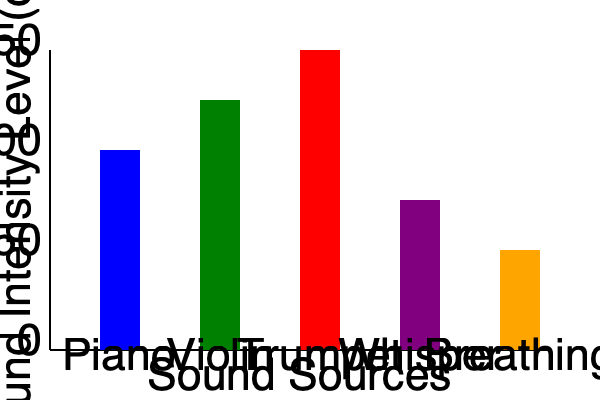Based on the graph comparing sound intensity levels of various musical instruments and everyday noises, which instrument has a sound intensity level closest to that of a whisper? To answer this question, we need to analyze the sound intensity levels represented by the heights of the bars in the graph. Let's go through the process step-by-step:

1. Identify the bar representing a whisper:
   The purple bar represents a whisper, with its base at the 200 dB mark.

2. Compare the heights of the instrument bars to the whisper bar:
   a) Piano (blue bar): Extends from about 150 dB to 350 dB
   b) Violin (green bar): Extends from about 100 dB to 350 dB
   c) Trumpet (red bar): Extends from about 50 dB to 350 dB

3. Evaluate which instrument bar is closest in height to the whisper bar:
   The piano bar starts closest to the base of the whisper bar, indicating that its minimum intensity is most similar to that of a whisper.

4. Consider the context of the persona:
   As a retired classical pianist who practices at low volumes, this comparison is particularly relevant. The piano's ability to produce soft sounds comparable to a whisper aligns with the persona's practice habits.

5. Conclusion:
   Among the given instruments, the piano has the sound intensity level closest to that of a whisper, especially at its lower range.
Answer: Piano 